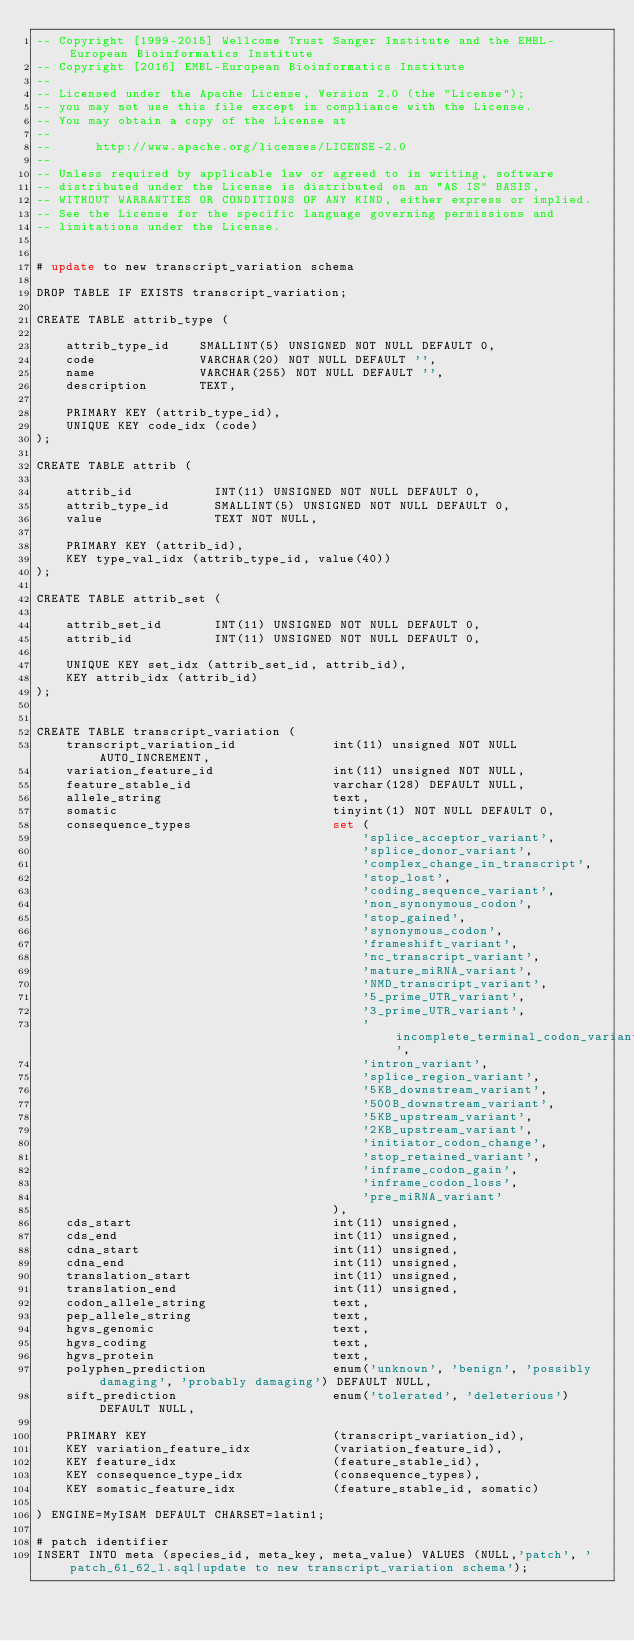<code> <loc_0><loc_0><loc_500><loc_500><_SQL_>-- Copyright [1999-2015] Wellcome Trust Sanger Institute and the EMBL-European Bioinformatics Institute
-- Copyright [2016] EMBL-European Bioinformatics Institute
-- 
-- Licensed under the Apache License, Version 2.0 (the "License");
-- you may not use this file except in compliance with the License.
-- You may obtain a copy of the License at
-- 
--      http://www.apache.org/licenses/LICENSE-2.0
-- 
-- Unless required by applicable law or agreed to in writing, software
-- distributed under the License is distributed on an "AS IS" BASIS,
-- WITHOUT WARRANTIES OR CONDITIONS OF ANY KIND, either express or implied.
-- See the License for the specific language governing permissions and
-- limitations under the License.


# update to new transcript_variation schema

DROP TABLE IF EXISTS transcript_variation;

CREATE TABLE attrib_type (

    attrib_type_id    SMALLINT(5) UNSIGNED NOT NULL DEFAULT 0,
    code              VARCHAR(20) NOT NULL DEFAULT '',
    name              VARCHAR(255) NOT NULL DEFAULT '',
    description       TEXT,

    PRIMARY KEY (attrib_type_id),
    UNIQUE KEY code_idx (code)
);

CREATE TABLE attrib (

    attrib_id           INT(11) UNSIGNED NOT NULL DEFAULT 0,
    attrib_type_id      SMALLINT(5) UNSIGNED NOT NULL DEFAULT 0,
    value               TEXT NOT NULL,

    PRIMARY KEY (attrib_id),
    KEY type_val_idx (attrib_type_id, value(40))
);

CREATE TABLE attrib_set (

    attrib_set_id       INT(11) UNSIGNED NOT NULL DEFAULT 0,
    attrib_id           INT(11) UNSIGNED NOT NULL DEFAULT 0,

    UNIQUE KEY set_idx (attrib_set_id, attrib_id),
    KEY attrib_idx (attrib_id)
);


CREATE TABLE transcript_variation (
    transcript_variation_id             int(11) unsigned NOT NULL AUTO_INCREMENT,
    variation_feature_id                int(11) unsigned NOT NULL,
    feature_stable_id                   varchar(128) DEFAULT NULL,
    allele_string                       text,
    somatic                             tinyint(1) NOT NULL DEFAULT 0,
    consequence_types                   set (
                                            'splice_acceptor_variant',
                                            'splice_donor_variant',
                                            'complex_change_in_transcript', 
                                            'stop_lost',
                                            'coding_sequence_variant',
                                            'non_synonymous_codon',
                                            'stop_gained',
                                            'synonymous_codon',
                                            'frameshift_variant',
                                            'nc_transcript_variant',
                                            'mature_miRNA_variant',
                                            'NMD_transcript_variant',
                                            '5_prime_UTR_variant',
                                            '3_prime_UTR_variant',
                                            'incomplete_terminal_codon_variant',
                                            'intron_variant',
                                            'splice_region_variant',
                                            '5KB_downstream_variant',
                                            '500B_downstream_variant',
                                            '5KB_upstream_variant',
                                            '2KB_upstream_variant',
                                            'initiator_codon_change',
                                            'stop_retained_variant',
                                            'inframe_codon_gain',
                                            'inframe_codon_loss',
                                            'pre_miRNA_variant'
                                        ),
    cds_start                           int(11) unsigned,
    cds_end                             int(11) unsigned,
    cdna_start                          int(11) unsigned,
    cdna_end                            int(11) unsigned,
    translation_start                   int(11) unsigned,
    translation_end                     int(11) unsigned,
    codon_allele_string                 text,
    pep_allele_string                   text,
    hgvs_genomic                        text,
    hgvs_coding                         text,
    hgvs_protein                        text,
    polyphen_prediction                 enum('unknown', 'benign', 'possibly damaging', 'probably damaging') DEFAULT NULL,
    sift_prediction                     enum('tolerated', 'deleterious') DEFAULT NULL,

    PRIMARY KEY                         (transcript_variation_id),
    KEY variation_feature_idx           (variation_feature_id),
    KEY feature_idx                     (feature_stable_id),
    KEY consequence_type_idx            (consequence_types),
    KEY somatic_feature_idx             (feature_stable_id, somatic)

) ENGINE=MyISAM DEFAULT CHARSET=latin1;

# patch identifier
INSERT INTO meta (species_id, meta_key, meta_value) VALUES (NULL,'patch', 'patch_61_62_l.sql|update to new transcript_variation schema');
</code> 